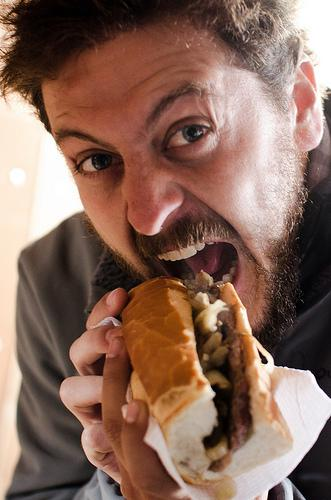Question: where was this photo taken?
Choices:
A. At a haunted house.
B. In a cemetary.
C. In a meeting.
D. At restaurant.
Answer with the letter. Answer: D Question: what type of of sandwich?
Choices:
A. A club sandwhich.
B. A hoagie.
C. A wrap.
D. A burrito.
Answer with the letter. Answer: B Question: what is the man doing?
Choices:
A. Laughing.
B. Talking.
C. Eating.
D. Drinking.
Answer with the letter. Answer: C Question: what is the man eating?
Choices:
A. An apple.
B. A banana.
C. A pear.
D. A sandwich.
Answer with the letter. Answer: D 